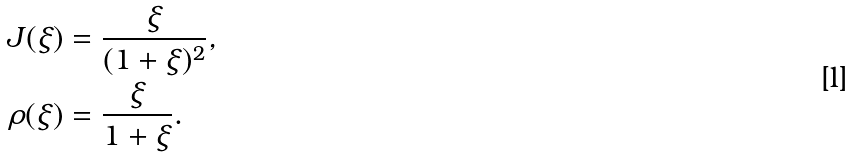Convert formula to latex. <formula><loc_0><loc_0><loc_500><loc_500>J ( \xi ) & = \frac { \xi } { ( 1 + \xi ) ^ { 2 } } , \\ \rho ( \xi ) & = \frac { \xi } { 1 + \xi } .</formula> 